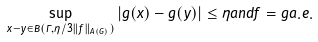Convert formula to latex. <formula><loc_0><loc_0><loc_500><loc_500>\sup _ { x - y \in B ( \Gamma , \eta / 3 \| f \| _ { A ( G ) } ) } { | g ( x ) - g ( y ) | } \leq \eta a n d f = g a . e .</formula> 